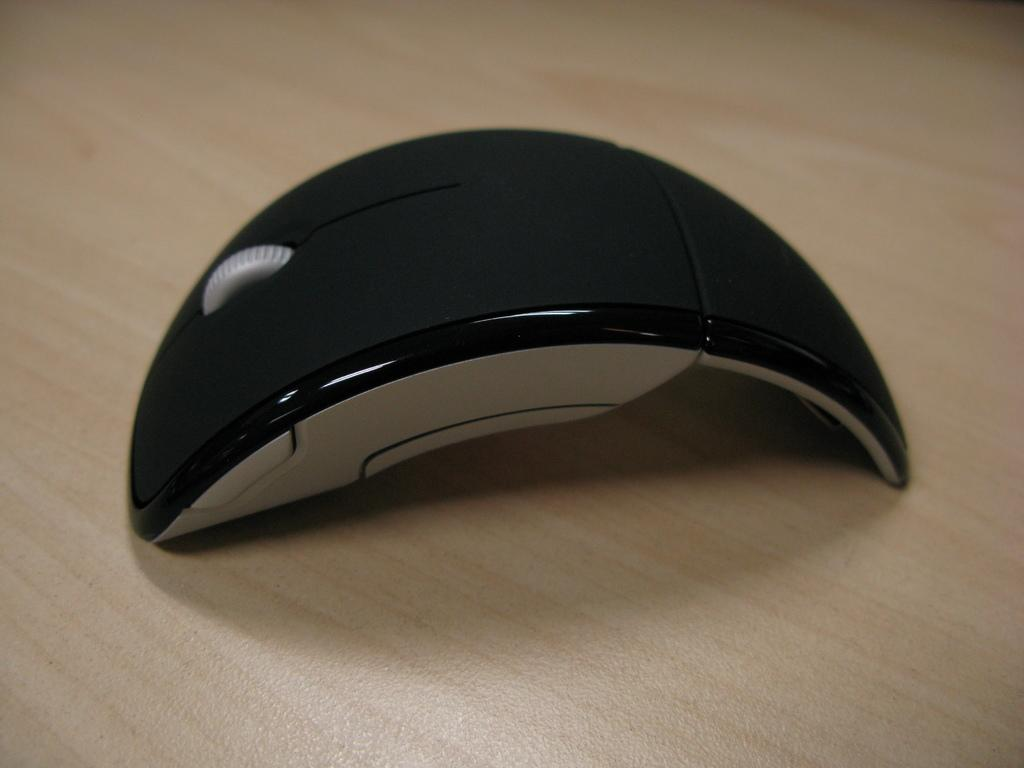What type of animal is in the image? There is a mouse in the image. What surface is the mouse on? The mouse is on a wooden surface. What type of stove can be seen in the image? There is no stove present in the image; it only features a mouse on a wooden surface. How many bananas are visible in the image? There are no bananas present in the image. 